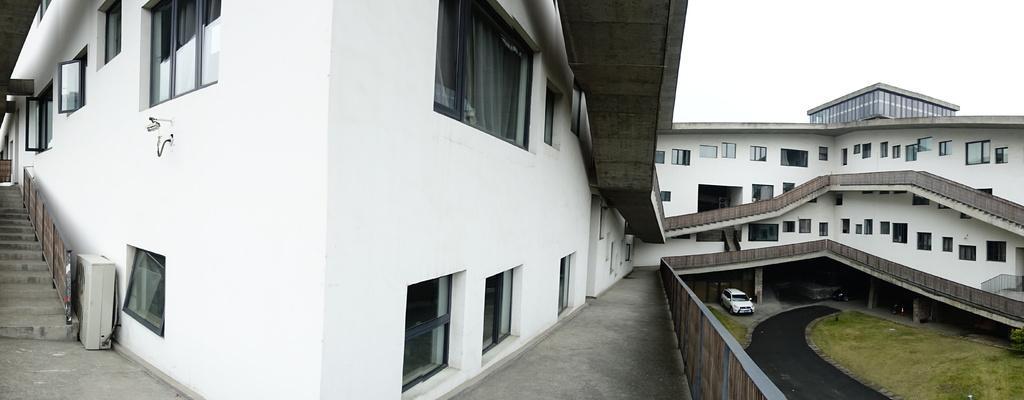Please provide a concise description of this image. In this picture I can see a building with windows, there are stars, there are vehicles, there is grass, and in the background there is the sky. 